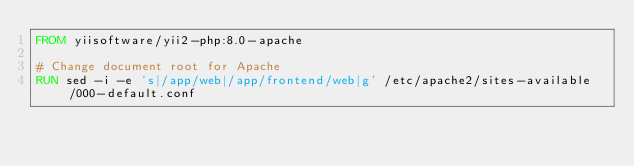Convert code to text. <code><loc_0><loc_0><loc_500><loc_500><_Dockerfile_>FROM yiisoftware/yii2-php:8.0-apache

# Change document root for Apache
RUN sed -i -e 's|/app/web|/app/frontend/web|g' /etc/apache2/sites-available/000-default.conf</code> 